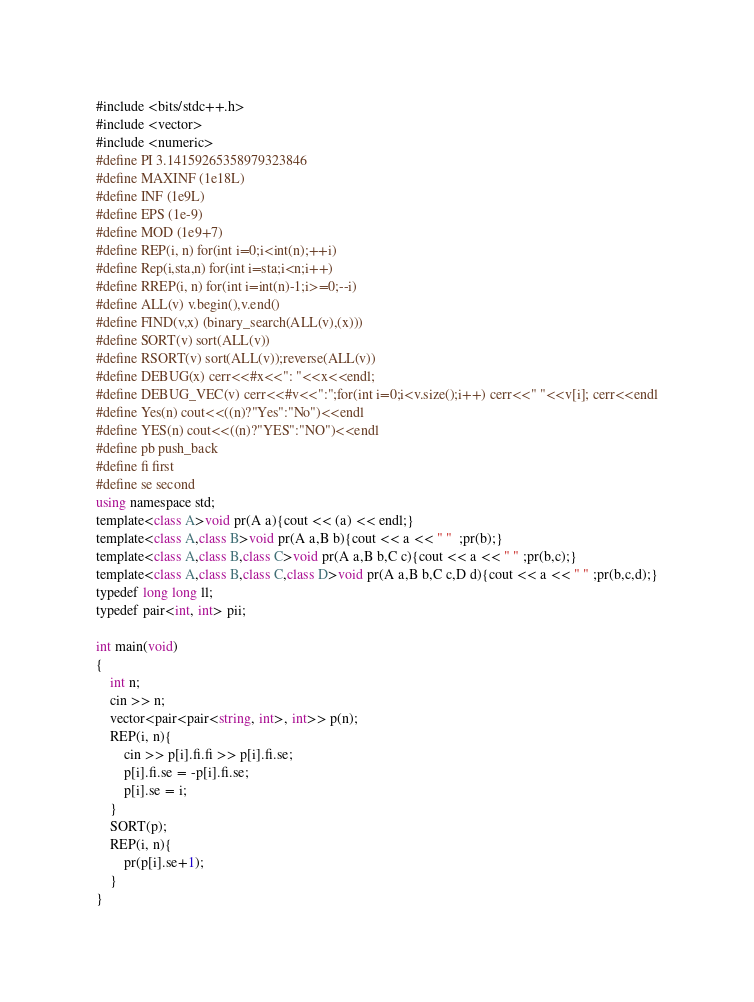Convert code to text. <code><loc_0><loc_0><loc_500><loc_500><_C#_>#include <bits/stdc++.h>
#include <vector>
#include <numeric>
#define PI 3.14159265358979323846
#define MAXINF (1e18L)
#define INF (1e9L)
#define EPS (1e-9)
#define MOD (1e9+7)
#define REP(i, n) for(int i=0;i<int(n);++i)
#define Rep(i,sta,n) for(int i=sta;i<n;i++)
#define RREP(i, n) for(int i=int(n)-1;i>=0;--i)
#define ALL(v) v.begin(),v.end()
#define FIND(v,x) (binary_search(ALL(v),(x)))
#define SORT(v) sort(ALL(v))
#define RSORT(v) sort(ALL(v));reverse(ALL(v))
#define DEBUG(x) cerr<<#x<<": "<<x<<endl;
#define DEBUG_VEC(v) cerr<<#v<<":";for(int i=0;i<v.size();i++) cerr<<" "<<v[i]; cerr<<endl
#define Yes(n) cout<<((n)?"Yes":"No")<<endl
#define YES(n) cout<<((n)?"YES":"NO")<<endl
#define pb push_back
#define fi first
#define se second
using namespace std;
template<class A>void pr(A a){cout << (a) << endl;}
template<class A,class B>void pr(A a,B b){cout << a << " "  ;pr(b);}
template<class A,class B,class C>void pr(A a,B b,C c){cout << a << " " ;pr(b,c);}
template<class A,class B,class C,class D>void pr(A a,B b,C c,D d){cout << a << " " ;pr(b,c,d);}
typedef long long ll;
typedef pair<int, int> pii;

int main(void)
{
    int n;
    cin >> n;
    vector<pair<pair<string, int>, int>> p(n);
    REP(i, n){
        cin >> p[i].fi.fi >> p[i].fi.se;
        p[i].fi.se = -p[i].fi.se;
        p[i].se = i;
    }
    SORT(p);
    REP(i, n){
        pr(p[i].se+1);
    }
}</code> 